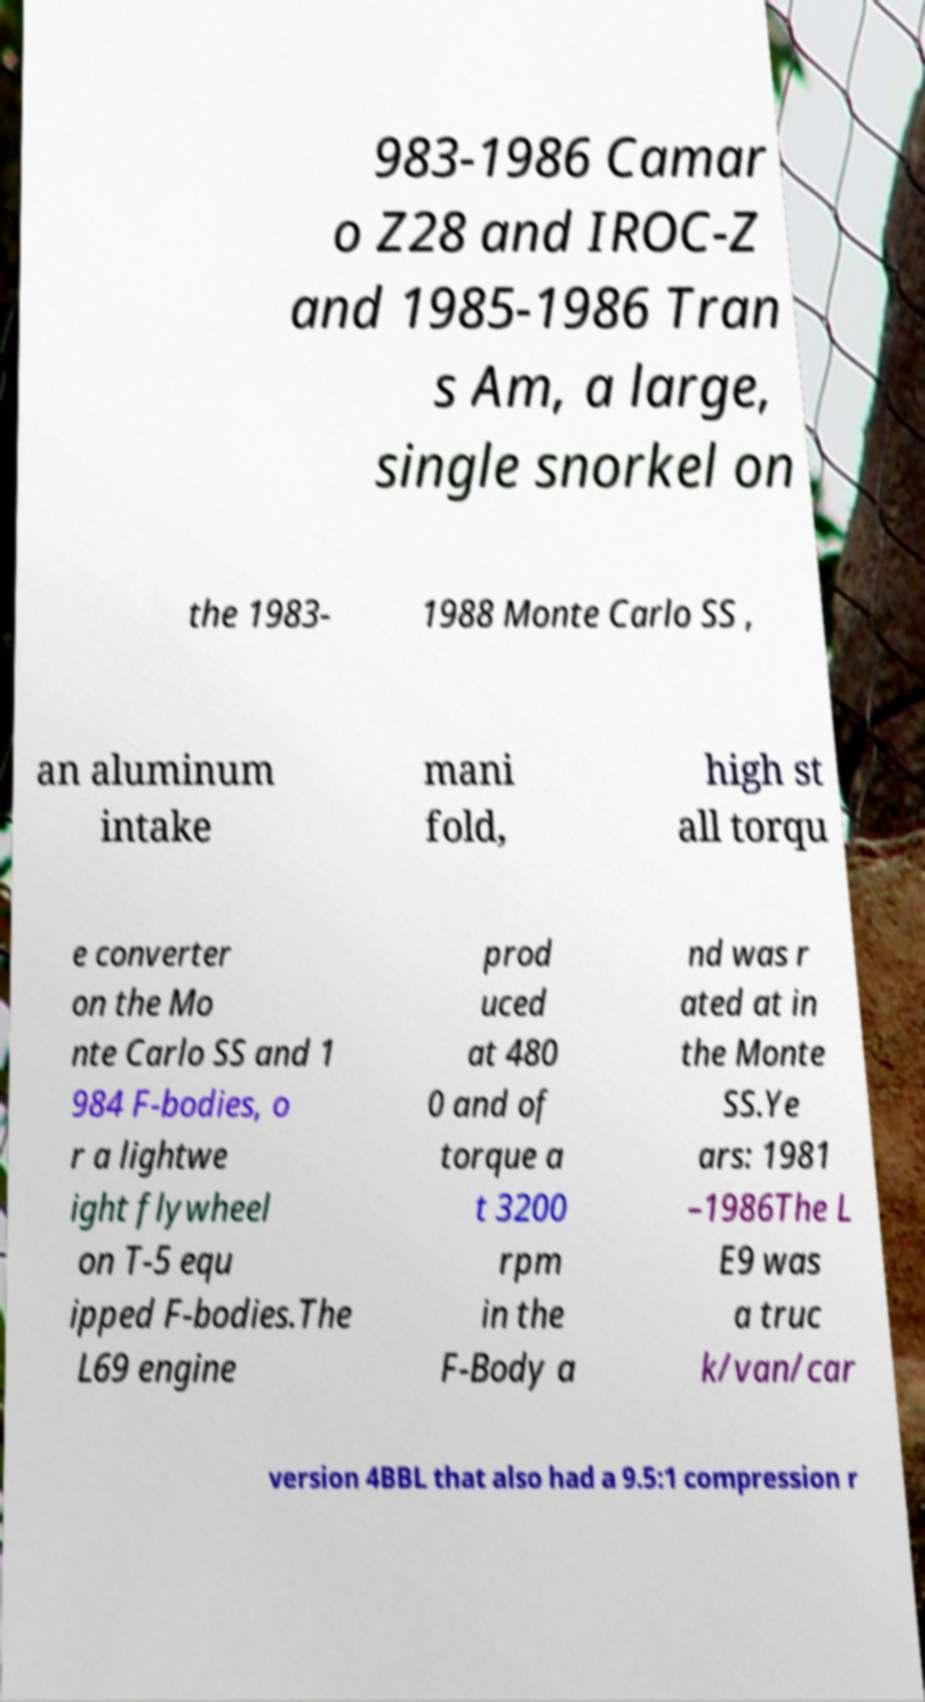Can you read and provide the text displayed in the image?This photo seems to have some interesting text. Can you extract and type it out for me? 983-1986 Camar o Z28 and IROC-Z and 1985-1986 Tran s Am, a large, single snorkel on the 1983- 1988 Monte Carlo SS , an aluminum intake mani fold, high st all torqu e converter on the Mo nte Carlo SS and 1 984 F-bodies, o r a lightwe ight flywheel on T-5 equ ipped F-bodies.The L69 engine prod uced at 480 0 and of torque a t 3200 rpm in the F-Body a nd was r ated at in the Monte SS.Ye ars: 1981 –1986The L E9 was a truc k/van/car version 4BBL that also had a 9.5:1 compression r 